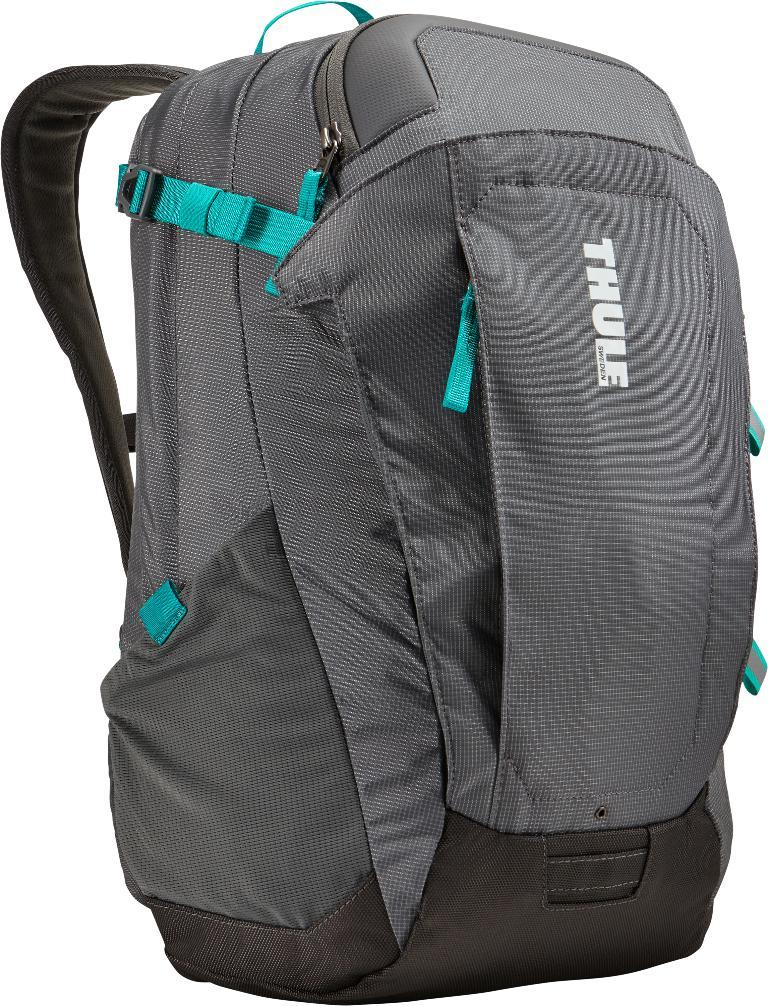Provide a one-sentence caption for the provided image. A Thule brand backpack from Sweden colored gray and black with teal.colored straps. 